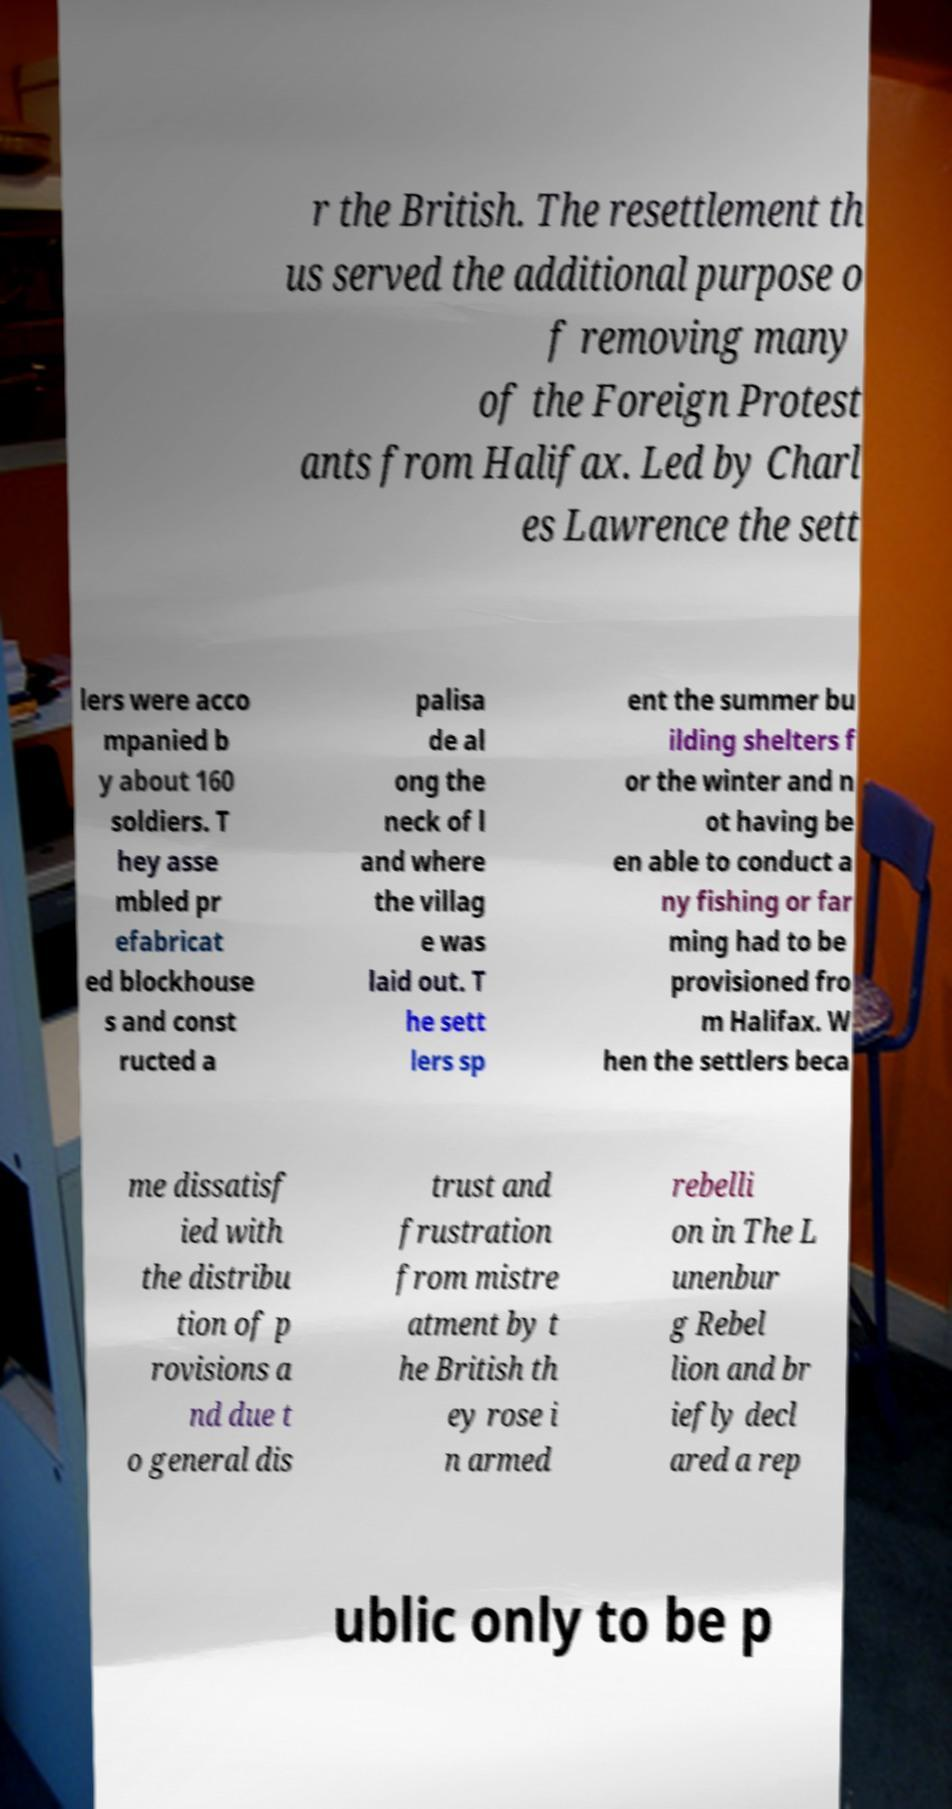What messages or text are displayed in this image? I need them in a readable, typed format. r the British. The resettlement th us served the additional purpose o f removing many of the Foreign Protest ants from Halifax. Led by Charl es Lawrence the sett lers were acco mpanied b y about 160 soldiers. T hey asse mbled pr efabricat ed blockhouse s and const ructed a palisa de al ong the neck of l and where the villag e was laid out. T he sett lers sp ent the summer bu ilding shelters f or the winter and n ot having be en able to conduct a ny fishing or far ming had to be provisioned fro m Halifax. W hen the settlers beca me dissatisf ied with the distribu tion of p rovisions a nd due t o general dis trust and frustration from mistre atment by t he British th ey rose i n armed rebelli on in The L unenbur g Rebel lion and br iefly decl ared a rep ublic only to be p 